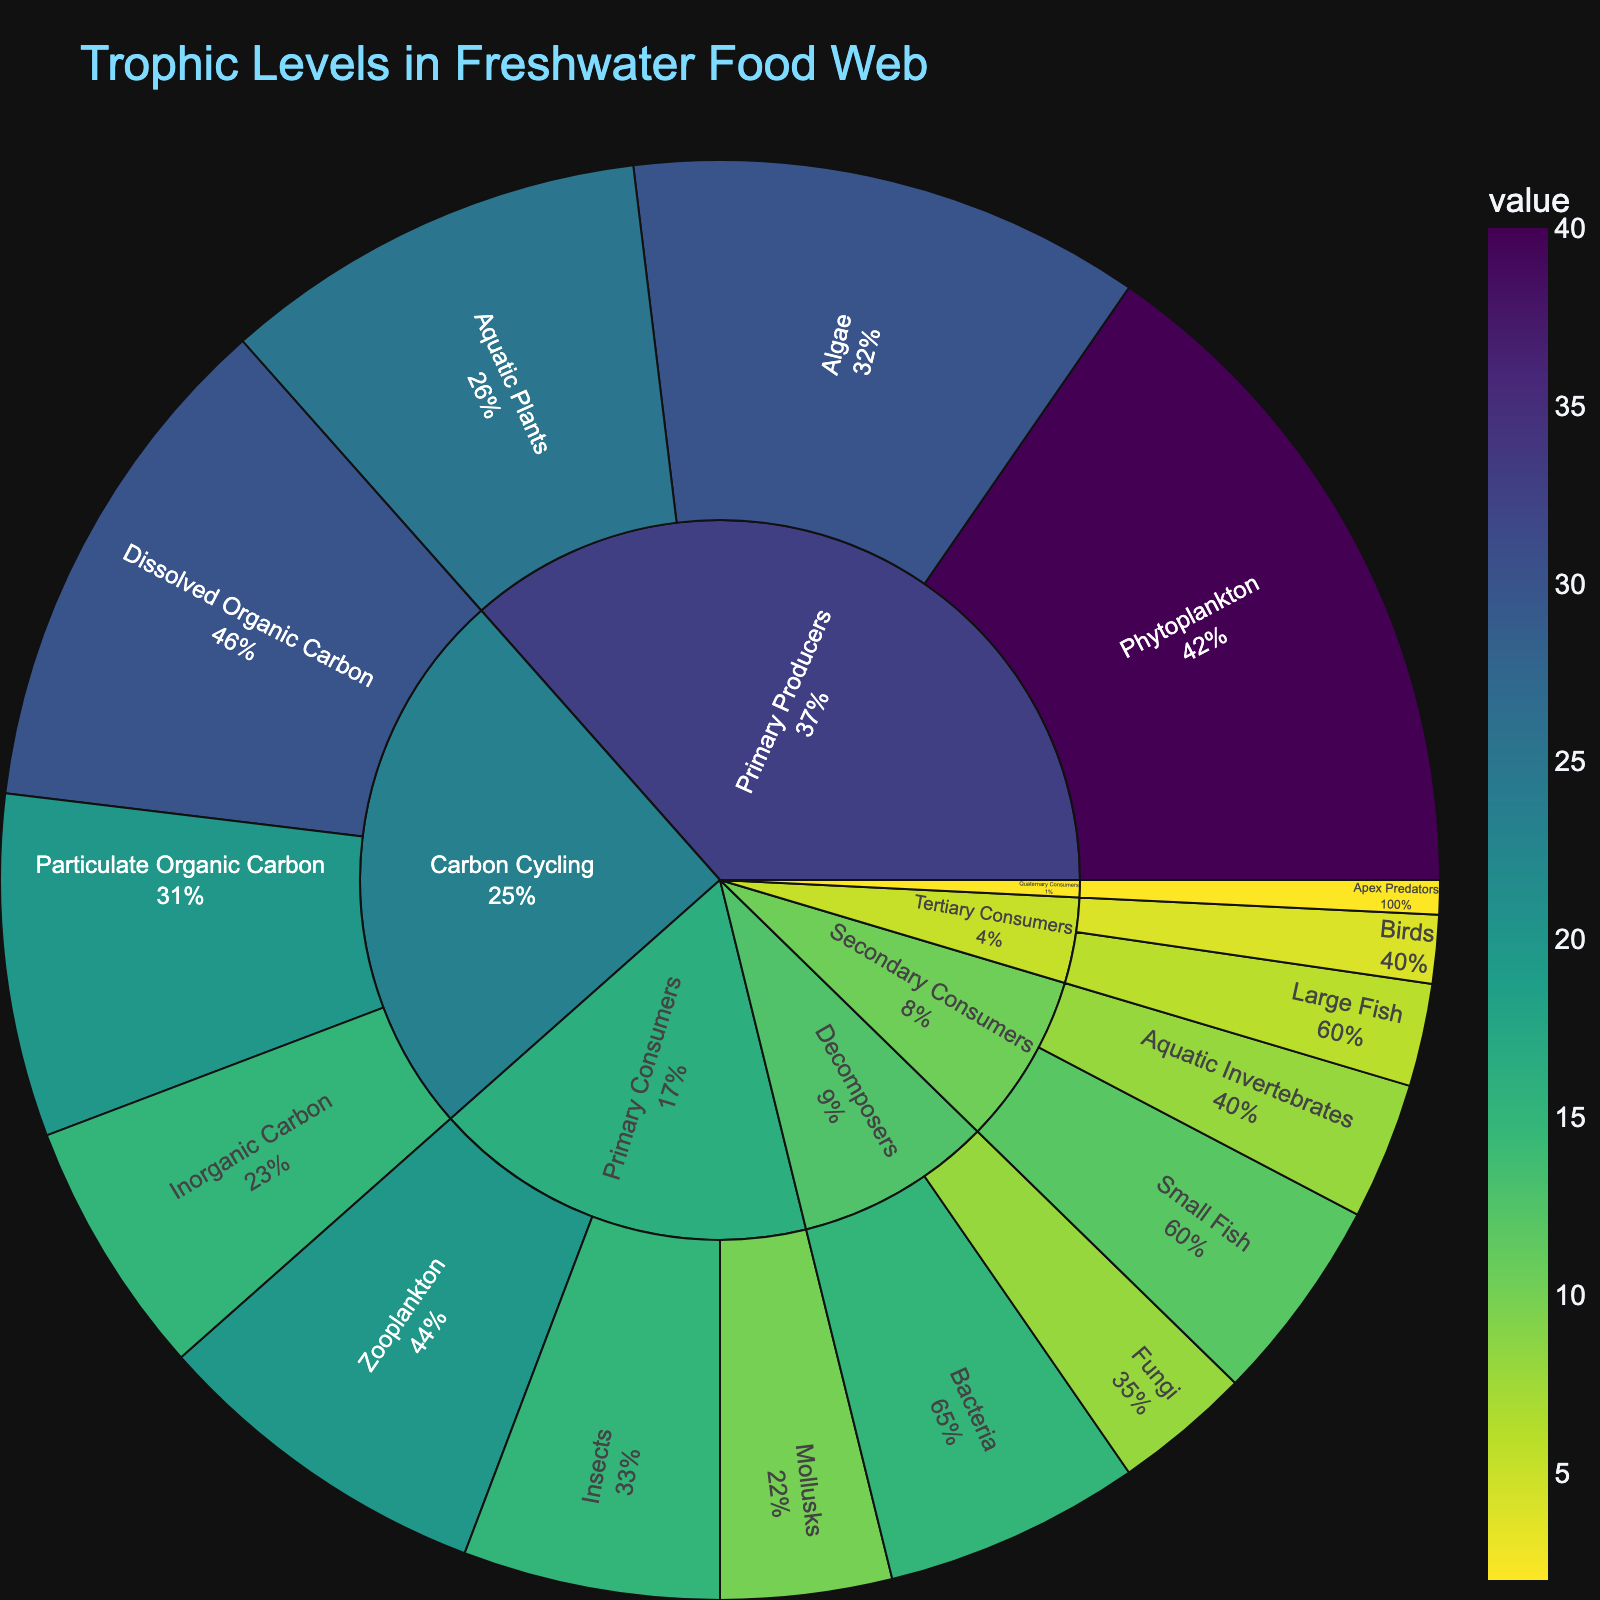What is the title of the sunburst plot? The title of the sunburst plot is typically found at the top of the figure. In this case, it states "Trophic Levels in Freshwater Food Web".
Answer: Trophic Levels in Freshwater Food Web Which category has the highest value in the plot? To find this, we look at the largest segment or section in the plot. The Primary Producers (Phytoplankton, Algae, Aquatic Plants) have the highest combined value among all categories.
Answer: Primary Producers What percentage of energy is transferred from Primary Producers to Primary Consumers? First, sum the values of Primary Producers (40+30+25=95), then sum the values of Primary Consumers (20+15+10=45). Calculate the percentage transferred: (45/95)*100 ≈ 47.37%.
Answer: 47.37% Which subcategory within Decomposers has the lowest value, and what is it? By examining the smaller sections of Decomposers, we see that Fungi has the lowest value. The value is 8.
Answer: Fungi, 8 Compare the value of Aquatic Plants and Apex Predators; which is greater? Identify and compare the values of Aquatic Plants (25) and Apex Predators (2).
Answer: Aquatic Plants What is the combined value of all Carbon Cycling subcategories? Add the values of all subcategories within Carbon Cycling: 30 (Dissolved Organic Carbon) + 20 (Particulate Organic Carbon) + 15 (Inorganic Carbon) = 65.
Answer: 65 How much greater is the value of Zooplankton compared to Small Fish? Subtract the value of Small Fish (12) from the value of Zooplankton (20): 20 - 12 = 8.
Answer: 8 Which subcategory has the highest percentage within Primary Consumers when compared to the total value of Primary Consumers? Within Primary Consumers, calculate the percentage of each subcategory: Zooplankton (20/45 ≈ 44.44%), Insects (15/45 ≈ 33.33%), Mollusks (10/45 ≈ 22.22%). Zooplankton has the highest percentage.
Answer: Zooplankton What is the average value of the subcategories under Secondary Consumers? Calculate the average by summing the values of Secondary Consumers (12+8=20) and dividing by the number of subcategories (2): 20 / 2 = 10.
Answer: 10 